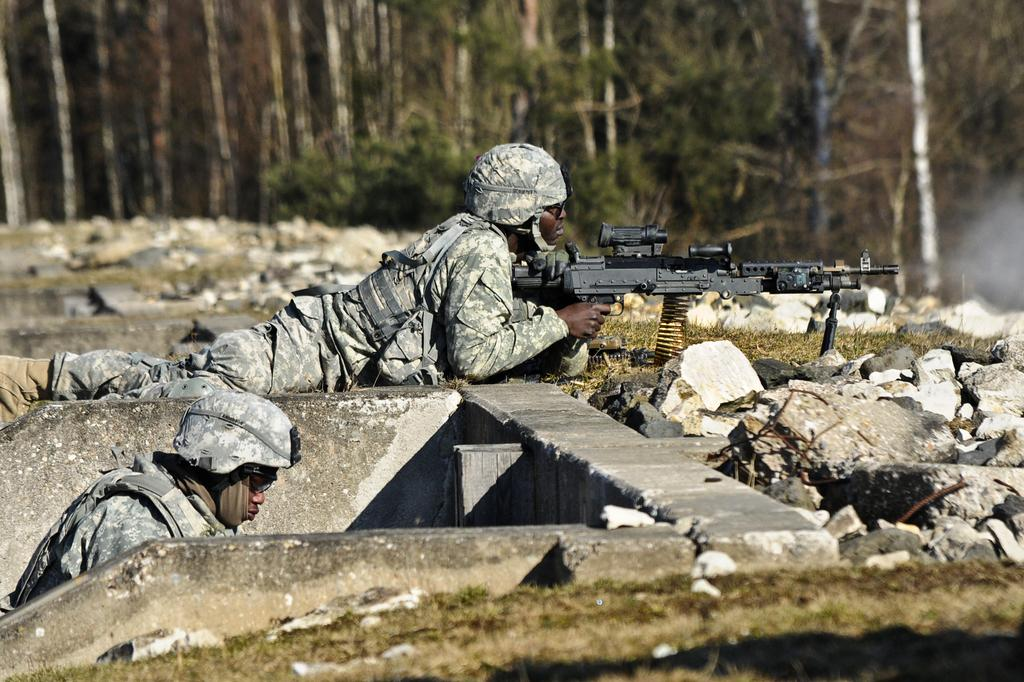How many people are in the image? There are two persons in the image. What are the people in the image doing? One person is lying down and holding a rifle. What type of natural features can be seen in the image? There are rocks and trees in the image. What year is depicted in the image? The image does not depict a specific year; it is a photograph or illustration of a scene. Who is the authority figure in the image? There is no authority figure present in the image; it features two people and natural elements. 